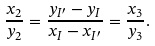Convert formula to latex. <formula><loc_0><loc_0><loc_500><loc_500>\frac { x _ { 2 } } { y _ { 2 } } = \frac { y _ { I ^ { \prime } } - y _ { I } } { x _ { I } - x _ { I ^ { \prime } } } = \frac { x _ { 3 } } { y _ { 3 } } .</formula> 